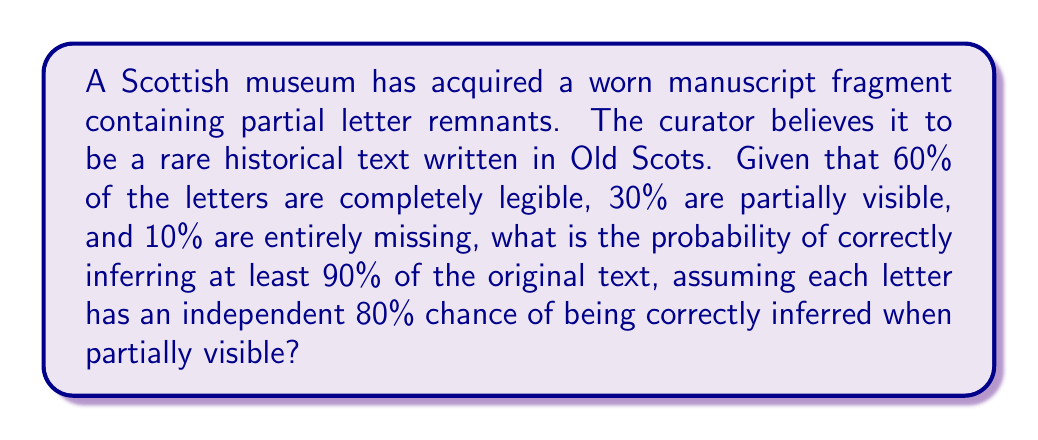What is the answer to this math problem? Let's approach this step-by-step:

1) First, we need to calculate the probability of correctly inferring each type of letter:
   - Completely legible letters: 100% chance
   - Partially visible letters: 80% chance (given)
   - Missing letters: 0% chance

2) Now, let's calculate the overall probability of correctly inferring any given letter:
   $P(\text{correct inference}) = 0.60 \times 1 + 0.30 \times 0.80 + 0.10 \times 0 = 0.84$

3) To infer at least 90% of the text correctly, we can allow for at most 10% errors. Let's call the number of letters in the manuscript $n$.

4) The number of correct inferences follows a binomial distribution with parameters $n$ and $p=0.84$. We want the probability of having at least $0.90n$ correct inferences.

5) Using the normal approximation to the binomial distribution (valid for large $n$), we can standardize this as:

   $$Z = \frac{0.90n - 0.84n}{\sqrt{n \times 0.84 \times 0.16}} = \frac{0.06n}{\sqrt{0.1344n}} = \frac{0.06\sqrt{n}}{\sqrt{0.1344}} = 0.1637\sqrt{n}$$

6) The probability we're looking for is $P(Z \geq 0.1637\sqrt{n})$, which equals $1 - \Phi(0.1637\sqrt{n})$, where $\Phi$ is the standard normal cumulative distribution function.

7) As $n$ increases, this probability will approach 1, meaning for sufficiently large manuscripts, we're very likely to infer at least 90% correctly.

8) For example, if $n = 1000$, we get:
   $P(Z \geq 0.1637\sqrt{1000}) = 1 - \Phi(5.1763) \approx 1 - 0.99999989 = 0.00000011$

This means for a 1000-letter manuscript, we have about a 0.000011% chance of correctly inferring at least 90% of the text.
Answer: $1 - \Phi(0.1637\sqrt{n})$, where $n$ is the number of letters and $\Phi$ is the standard normal CDF. 